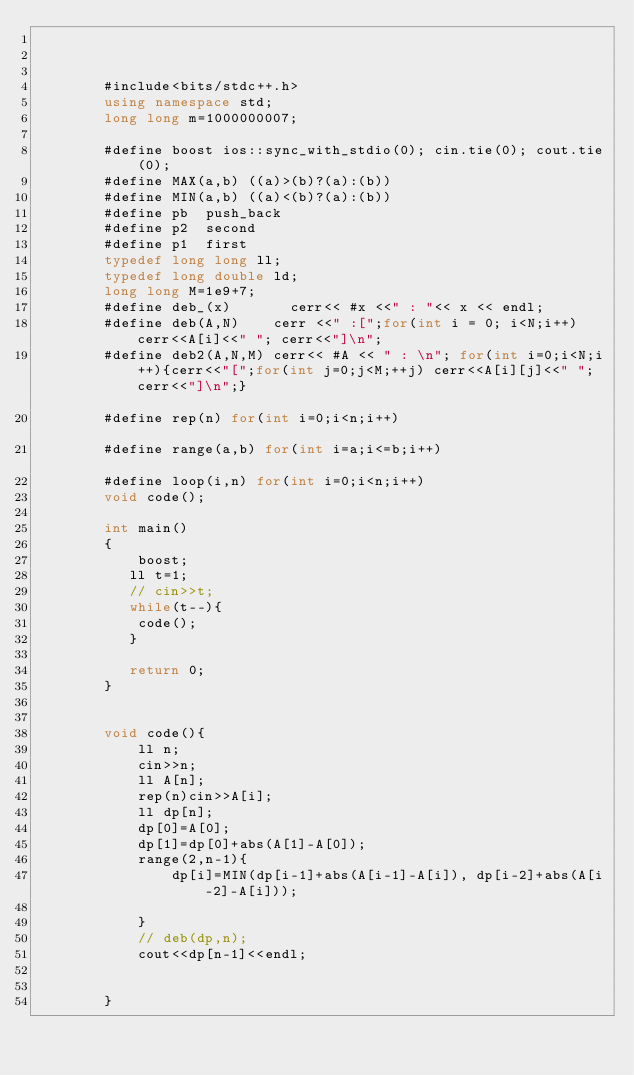Convert code to text. <code><loc_0><loc_0><loc_500><loc_500><_C++_>

     
        #include<bits/stdc++.h>
        using namespace std;
        long long m=1000000007;
     
        #define boost ios::sync_with_stdio(0); cin.tie(0); cout.tie(0);
        #define MAX(a,b) ((a)>(b)?(a):(b))
        #define MIN(a,b) ((a)<(b)?(a):(b))
        #define pb  push_back
        #define p2  second
        #define p1  first
        typedef long long ll;
        typedef long double ld; 
        long long M=1e9+7;			
        #define deb_(x)       cerr<< #x <<" : "<< x << endl;
        #define deb(A,N)    cerr <<" :[";for(int i = 0; i<N;i++) cerr<<A[i]<<" "; cerr<<"]\n";
        #define deb2(A,N,M) cerr<< #A << " : \n"; for(int i=0;i<N;i++){cerr<<"[";for(int j=0;j<M;++j) cerr<<A[i][j]<<" ";cerr<<"]\n";}																				
        #define rep(n) for(int i=0;i<n;i++)																		
        #define range(a,b) for(int i=a;i<=b;i++)																	
        #define loop(i,n) for(int i=0;i<n;i++)
    	void code();
     
        int main()
        {   
        	boost;
           ll t=1;
           // cin>>t;
           while(t--){
           	code();
           }
         
           return 0;
        }
     
       
        void code(){
        	ll n;
        	cin>>n;
        	ll A[n];
        	rep(n)cin>>A[i];
        	ll dp[n];
        	dp[0]=A[0];
        	dp[1]=dp[0]+abs(A[1]-A[0]);
        	range(2,n-1){
        		dp[i]=MIN(dp[i-1]+abs(A[i-1]-A[i]), dp[i-2]+abs(A[i-2]-A[i]));

        	}
        	// deb(dp,n);
        	cout<<dp[n-1]<<endl;

       	
        }</code> 